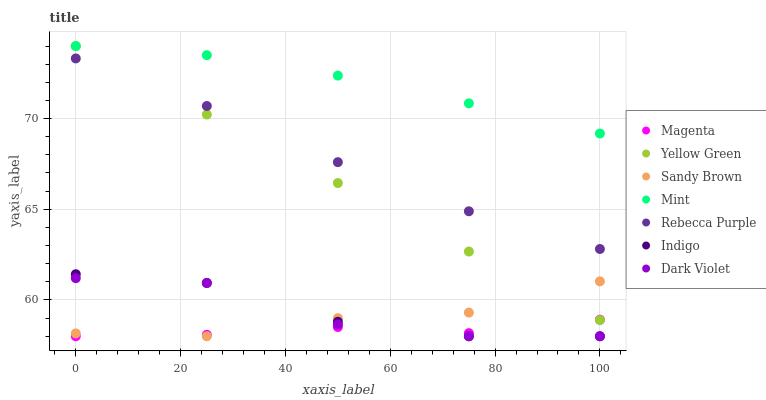Does Magenta have the minimum area under the curve?
Answer yes or no. Yes. Does Mint have the maximum area under the curve?
Answer yes or no. Yes. Does Yellow Green have the minimum area under the curve?
Answer yes or no. No. Does Yellow Green have the maximum area under the curve?
Answer yes or no. No. Is Yellow Green the smoothest?
Answer yes or no. Yes. Is Dark Violet the roughest?
Answer yes or no. Yes. Is Sandy Brown the smoothest?
Answer yes or no. No. Is Sandy Brown the roughest?
Answer yes or no. No. Does Indigo have the lowest value?
Answer yes or no. Yes. Does Yellow Green have the lowest value?
Answer yes or no. No. Does Yellow Green have the highest value?
Answer yes or no. Yes. Does Sandy Brown have the highest value?
Answer yes or no. No. Is Sandy Brown less than Mint?
Answer yes or no. Yes. Is Mint greater than Dark Violet?
Answer yes or no. Yes. Does Mint intersect Yellow Green?
Answer yes or no. Yes. Is Mint less than Yellow Green?
Answer yes or no. No. Is Mint greater than Yellow Green?
Answer yes or no. No. Does Sandy Brown intersect Mint?
Answer yes or no. No. 